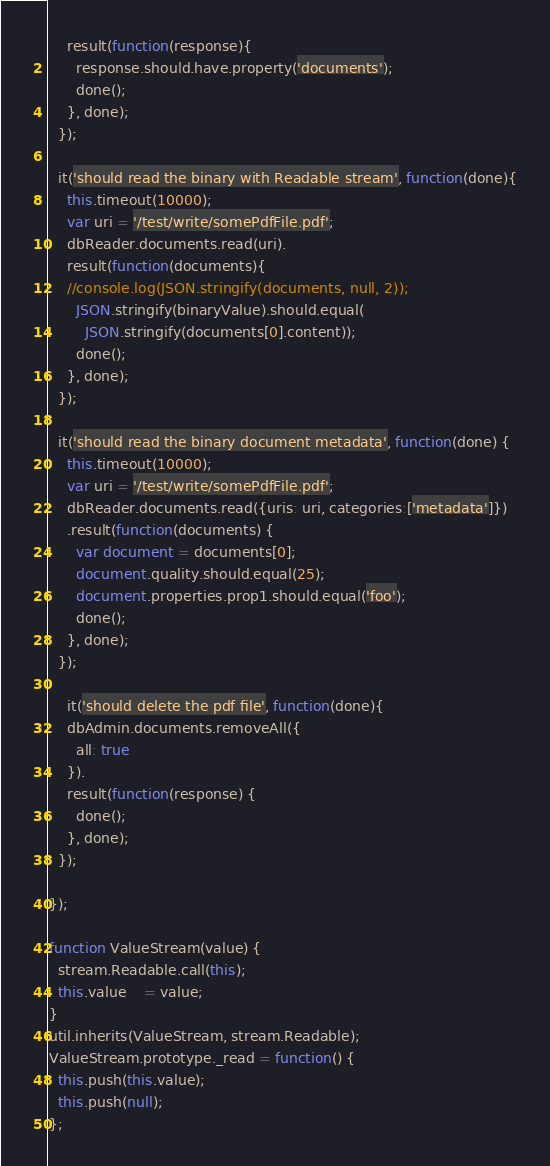Convert code to text. <code><loc_0><loc_0><loc_500><loc_500><_JavaScript_>    result(function(response){
      response.should.have.property('documents');
      done();
    }, done);   
  });

  it('should read the binary with Readable stream', function(done){
    this.timeout(10000);
    var uri = '/test/write/somePdfFile.pdf';
    dbReader.documents.read(uri).
    result(function(documents){
    //console.log(JSON.stringify(documents, null, 2));
      JSON.stringify(binaryValue).should.equal(
        JSON.stringify(documents[0].content));
      done();
    }, done);   
  });

  it('should read the binary document metadata', function(done) {
    this.timeout(10000);
    var uri = '/test/write/somePdfFile.pdf';
    dbReader.documents.read({uris: uri, categories:['metadata']})
    .result(function(documents) {
      var document = documents[0];
      document.quality.should.equal(25);
      document.properties.prop1.should.equal('foo');
      done();
    }, done);
  });
  
    it('should delete the pdf file', function(done){
    dbAdmin.documents.removeAll({
      all: true
    }).
    result(function(response) {
      done();
    }, done);
  }); 

});

function ValueStream(value) {
  stream.Readable.call(this);
  this.value    = value;
}
util.inherits(ValueStream, stream.Readable);
ValueStream.prototype._read = function() {
  this.push(this.value);
  this.push(null);
};
</code> 